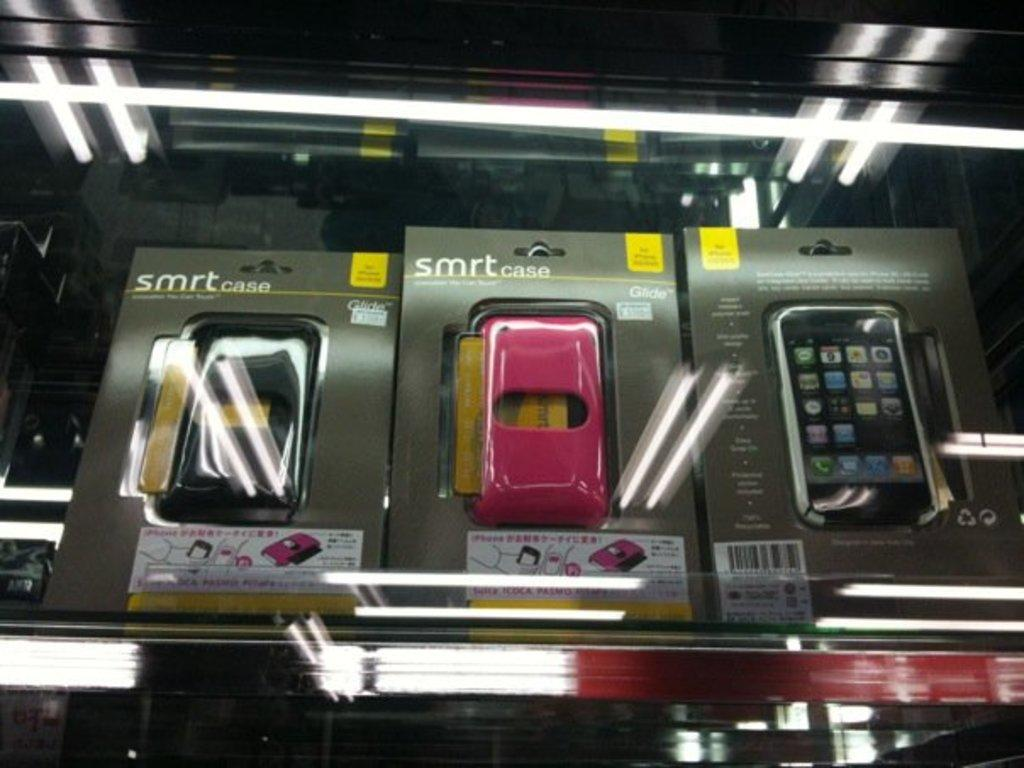<image>
Summarize the visual content of the image. A row of cell phone cases in packaging that says smrt case are on a store shelf. 